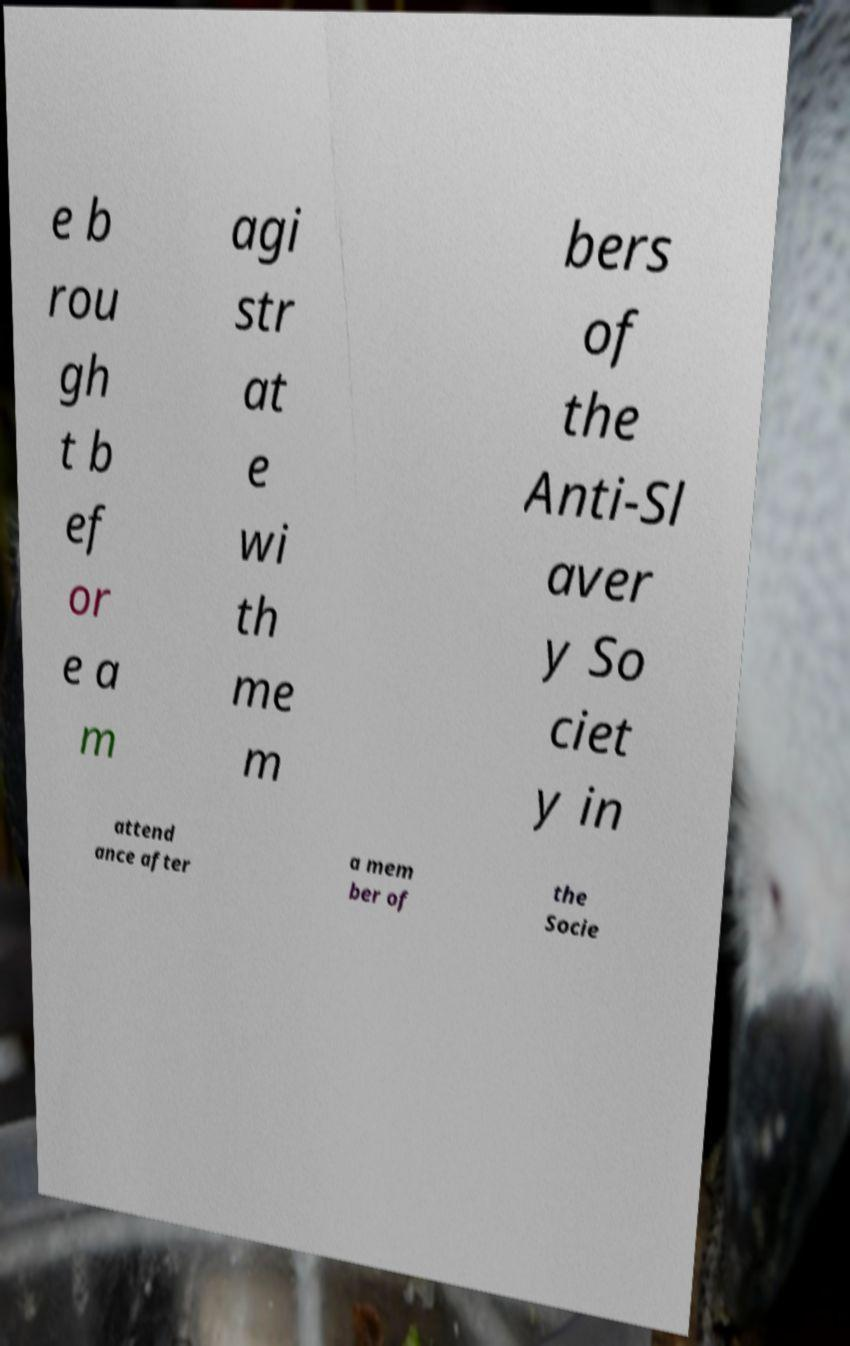There's text embedded in this image that I need extracted. Can you transcribe it verbatim? e b rou gh t b ef or e a m agi str at e wi th me m bers of the Anti-Sl aver y So ciet y in attend ance after a mem ber of the Socie 